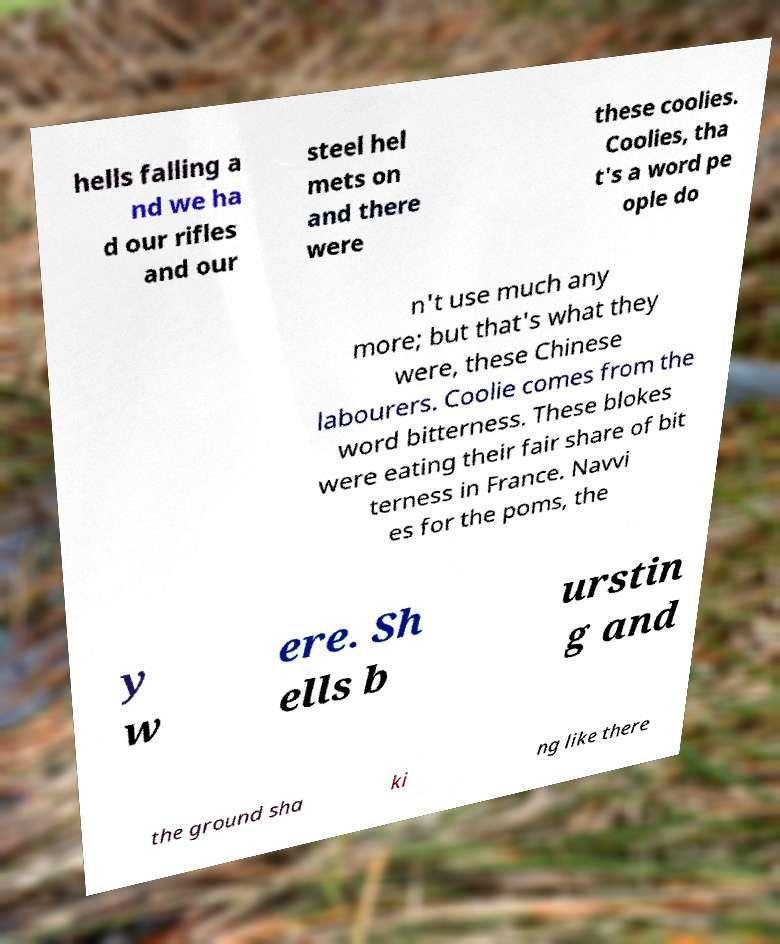There's text embedded in this image that I need extracted. Can you transcribe it verbatim? hells falling a nd we ha d our rifles and our steel hel mets on and there were these coolies. Coolies, tha t's a word pe ople do n't use much any more; but that's what they were, these Chinese labourers. Coolie comes from the word bitterness. These blokes were eating their fair share of bit terness in France. Navvi es for the poms, the y w ere. Sh ells b urstin g and the ground sha ki ng like there 